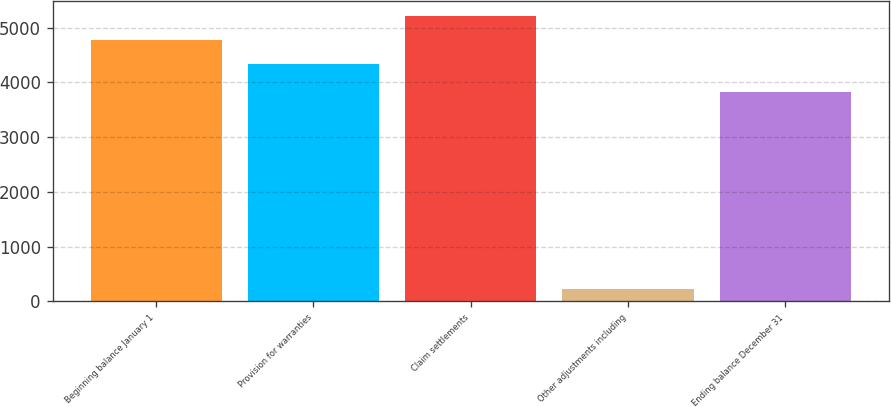<chart> <loc_0><loc_0><loc_500><loc_500><bar_chart><fcel>Beginning balance January 1<fcel>Provision for warranties<fcel>Claim settlements<fcel>Other adjustments including<fcel>Ending balance December 31<nl><fcel>4775.7<fcel>4331<fcel>5220.4<fcel>218<fcel>3831<nl></chart> 